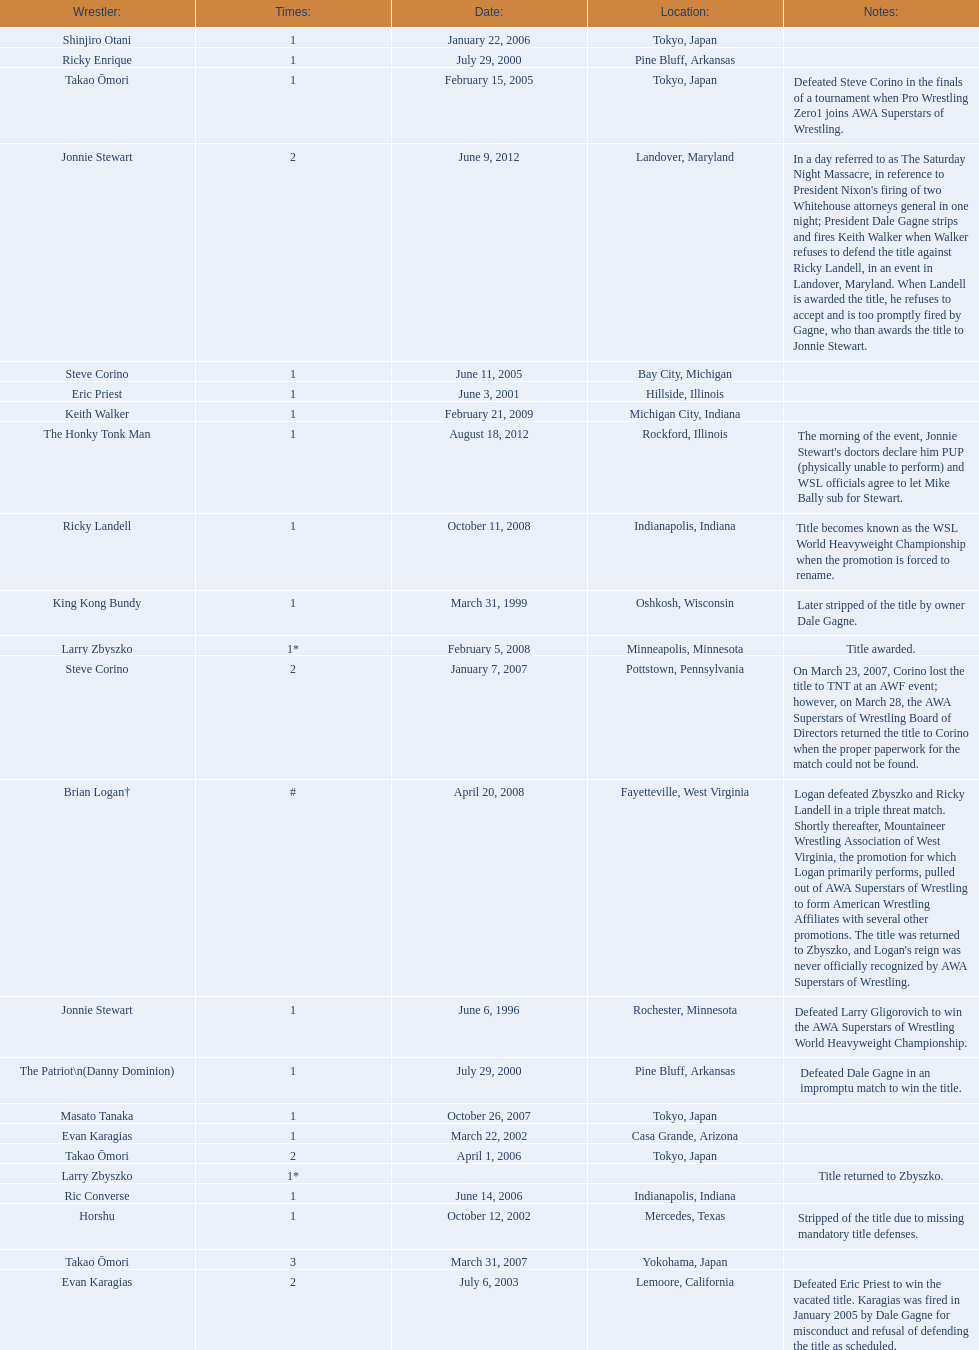Where are the title holders from? Rochester, Minnesota, Oshkosh, Wisconsin, Pine Bluff, Arkansas, Pine Bluff, Arkansas, Hillside, Illinois, Casa Grande, Arizona, Mercedes, Texas, Lemoore, California, Tokyo, Japan, Bay City, Michigan, Tokyo, Japan, Tokyo, Japan, Indianapolis, Indiana, Pottstown, Pennsylvania, Yokohama, Japan, Tokyo, Japan, Minneapolis, Minnesota, Fayetteville, West Virginia, , Indianapolis, Indiana, Michigan City, Indiana, Landover, Maryland, Rockford, Illinois. Who is the title holder from texas? Horshu. 